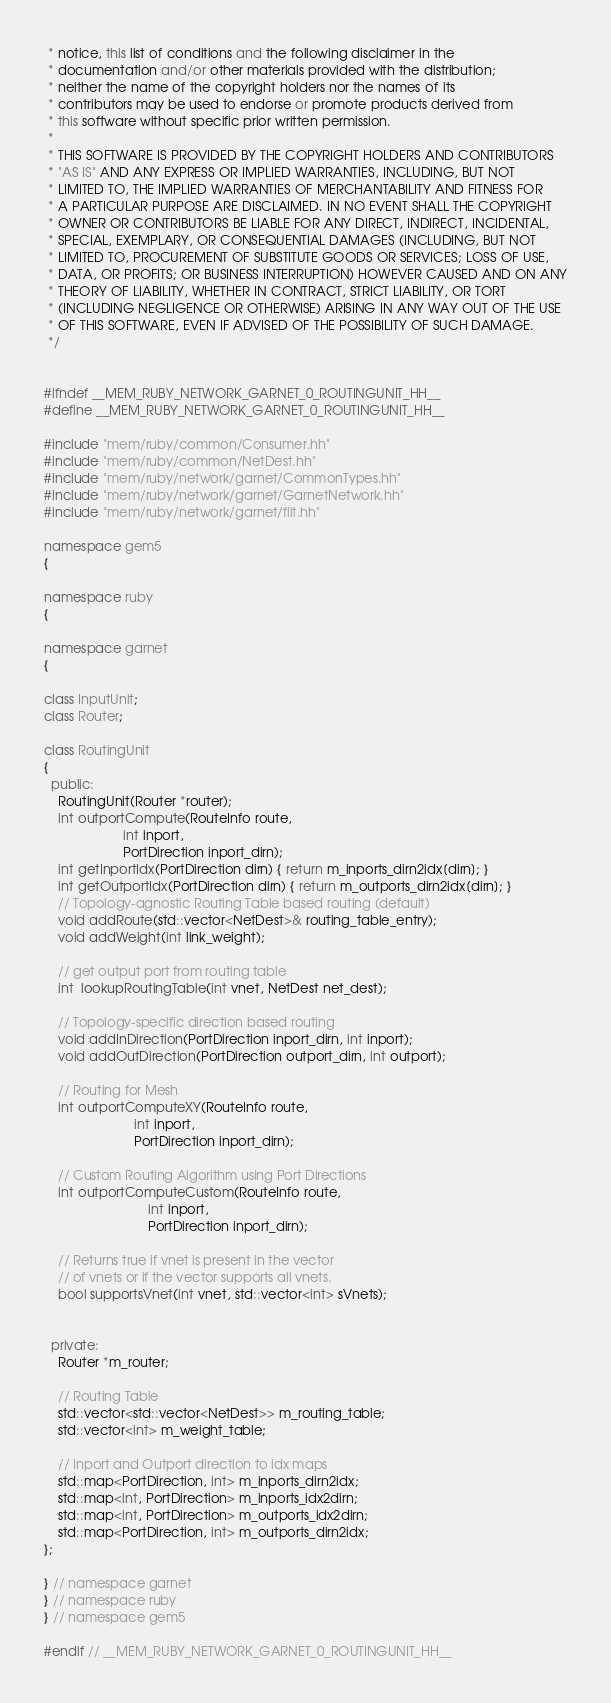<code> <loc_0><loc_0><loc_500><loc_500><_C++_> * notice, this list of conditions and the following disclaimer in the
 * documentation and/or other materials provided with the distribution;
 * neither the name of the copyright holders nor the names of its
 * contributors may be used to endorse or promote products derived from
 * this software without specific prior written permission.
 *
 * THIS SOFTWARE IS PROVIDED BY THE COPYRIGHT HOLDERS AND CONTRIBUTORS
 * "AS IS" AND ANY EXPRESS OR IMPLIED WARRANTIES, INCLUDING, BUT NOT
 * LIMITED TO, THE IMPLIED WARRANTIES OF MERCHANTABILITY AND FITNESS FOR
 * A PARTICULAR PURPOSE ARE DISCLAIMED. IN NO EVENT SHALL THE COPYRIGHT
 * OWNER OR CONTRIBUTORS BE LIABLE FOR ANY DIRECT, INDIRECT, INCIDENTAL,
 * SPECIAL, EXEMPLARY, OR CONSEQUENTIAL DAMAGES (INCLUDING, BUT NOT
 * LIMITED TO, PROCUREMENT OF SUBSTITUTE GOODS OR SERVICES; LOSS OF USE,
 * DATA, OR PROFITS; OR BUSINESS INTERRUPTION) HOWEVER CAUSED AND ON ANY
 * THEORY OF LIABILITY, WHETHER IN CONTRACT, STRICT LIABILITY, OR TORT
 * (INCLUDING NEGLIGENCE OR OTHERWISE) ARISING IN ANY WAY OUT OF THE USE
 * OF THIS SOFTWARE, EVEN IF ADVISED OF THE POSSIBILITY OF SUCH DAMAGE.
 */


#ifndef __MEM_RUBY_NETWORK_GARNET_0_ROUTINGUNIT_HH__
#define __MEM_RUBY_NETWORK_GARNET_0_ROUTINGUNIT_HH__

#include "mem/ruby/common/Consumer.hh"
#include "mem/ruby/common/NetDest.hh"
#include "mem/ruby/network/garnet/CommonTypes.hh"
#include "mem/ruby/network/garnet/GarnetNetwork.hh"
#include "mem/ruby/network/garnet/flit.hh"

namespace gem5
{

namespace ruby
{

namespace garnet
{

class InputUnit;
class Router;

class RoutingUnit
{
  public:
    RoutingUnit(Router *router);
    int outportCompute(RouteInfo route,
                      int inport,
                      PortDirection inport_dirn);
    int getInportIdx(PortDirection dirn) { return m_inports_dirn2idx[dirn]; }
    int getOutportIdx(PortDirection dirn) { return m_outports_dirn2idx[dirn]; }
    // Topology-agnostic Routing Table based routing (default)
    void addRoute(std::vector<NetDest>& routing_table_entry);
    void addWeight(int link_weight);

    // get output port from routing table
    int  lookupRoutingTable(int vnet, NetDest net_dest);

    // Topology-specific direction based routing
    void addInDirection(PortDirection inport_dirn, int inport);
    void addOutDirection(PortDirection outport_dirn, int outport);

    // Routing for Mesh
    int outportComputeXY(RouteInfo route,
                         int inport,
                         PortDirection inport_dirn);

    // Custom Routing Algorithm using Port Directions
    int outportComputeCustom(RouteInfo route,
                             int inport,
                             PortDirection inport_dirn);

    // Returns true if vnet is present in the vector
    // of vnets or if the vector supports all vnets.
    bool supportsVnet(int vnet, std::vector<int> sVnets);


  private:
    Router *m_router;

    // Routing Table
    std::vector<std::vector<NetDest>> m_routing_table;
    std::vector<int> m_weight_table;

    // Inport and Outport direction to idx maps
    std::map<PortDirection, int> m_inports_dirn2idx;
    std::map<int, PortDirection> m_inports_idx2dirn;
    std::map<int, PortDirection> m_outports_idx2dirn;
    std::map<PortDirection, int> m_outports_dirn2idx;
};

} // namespace garnet
} // namespace ruby
} // namespace gem5

#endif // __MEM_RUBY_NETWORK_GARNET_0_ROUTINGUNIT_HH__
</code> 